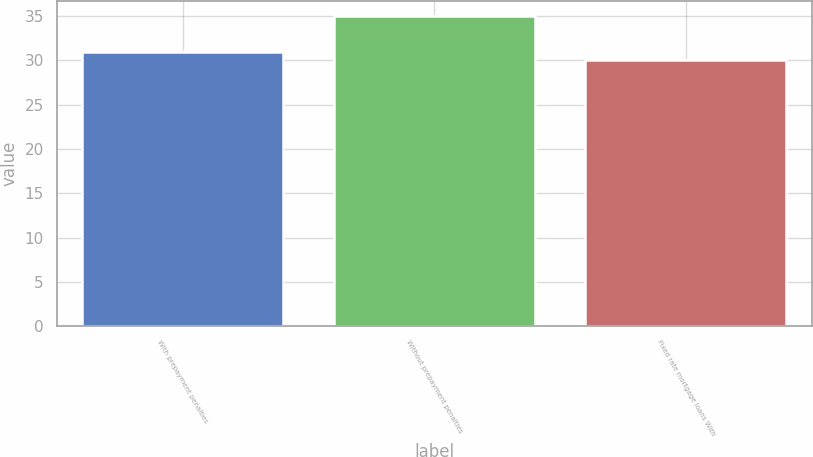Convert chart to OTSL. <chart><loc_0><loc_0><loc_500><loc_500><bar_chart><fcel>With prepayment penalties<fcel>Without prepayment penalties<fcel>Fixed rate mortgage loans With<nl><fcel>31<fcel>35<fcel>30<nl></chart> 